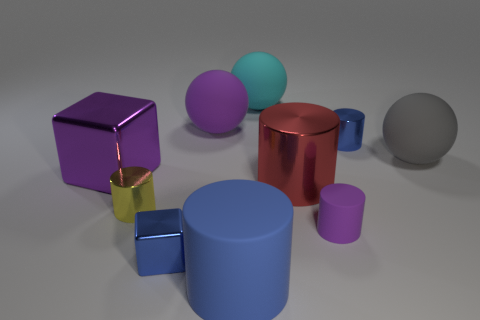Subtract 1 cylinders. How many cylinders are left? 4 Subtract all small yellow metallic cylinders. How many cylinders are left? 4 Subtract all red cylinders. How many cylinders are left? 4 Subtract all cyan cylinders. Subtract all purple cubes. How many cylinders are left? 5 Subtract all balls. How many objects are left? 7 Add 3 rubber balls. How many rubber balls are left? 6 Add 3 blue rubber cubes. How many blue rubber cubes exist? 3 Subtract 0 brown cylinders. How many objects are left? 10 Subtract all large gray spheres. Subtract all yellow things. How many objects are left? 8 